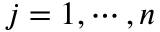<formula> <loc_0><loc_0><loc_500><loc_500>j = 1 , \cdots , n</formula> 